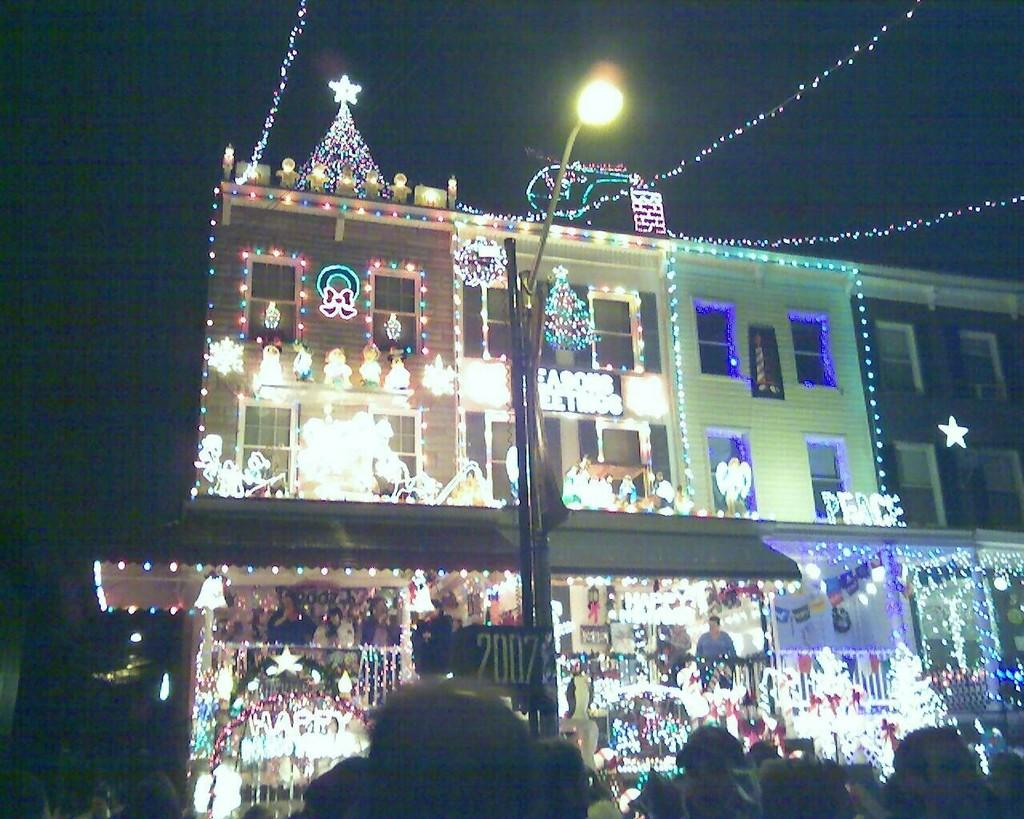What type of structure is present in the image? There is a building in the picture. How is the building decorated or illuminated? The building is arranged with lights. What other object can be seen in the image? There is a pole in the picture. What is on top of the pole? There is a light on the pole. What feature of the building is mentioned in the facts? The building has windows. How would you describe the sky in the image? The sky is dark in the picture. What type of nut is being used to hold the building together in the image? There is no nut present in the image, and the building is not being held together by any nuts. What type of grain can be seen growing on the side of the building in the image? There is no grain present on the side of the building in the image. 